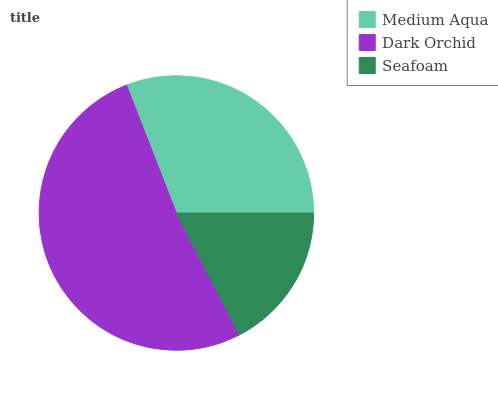Is Seafoam the minimum?
Answer yes or no. Yes. Is Dark Orchid the maximum?
Answer yes or no. Yes. Is Dark Orchid the minimum?
Answer yes or no. No. Is Seafoam the maximum?
Answer yes or no. No. Is Dark Orchid greater than Seafoam?
Answer yes or no. Yes. Is Seafoam less than Dark Orchid?
Answer yes or no. Yes. Is Seafoam greater than Dark Orchid?
Answer yes or no. No. Is Dark Orchid less than Seafoam?
Answer yes or no. No. Is Medium Aqua the high median?
Answer yes or no. Yes. Is Medium Aqua the low median?
Answer yes or no. Yes. Is Seafoam the high median?
Answer yes or no. No. Is Seafoam the low median?
Answer yes or no. No. 